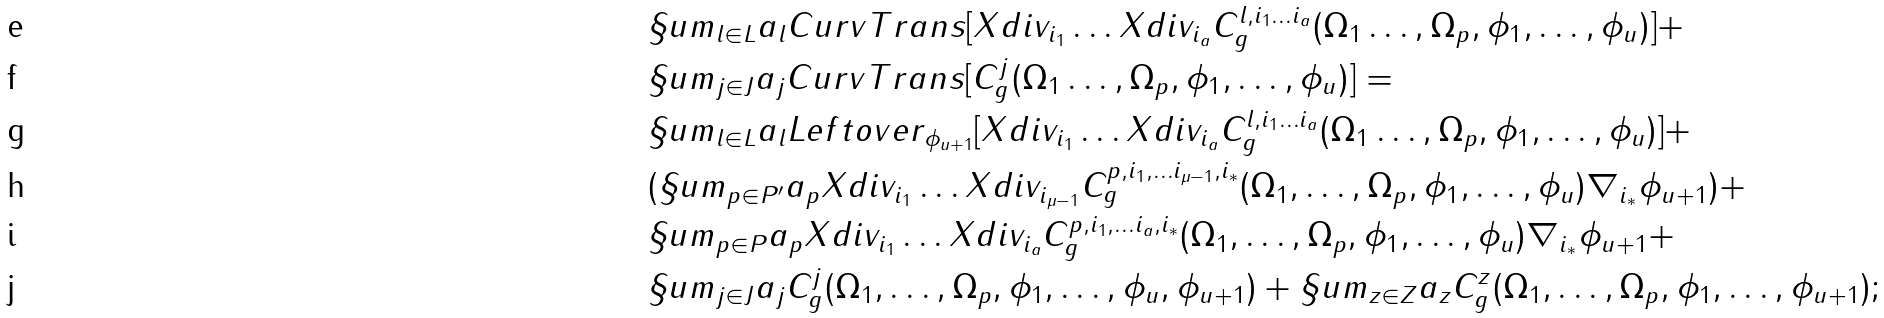Convert formula to latex. <formula><loc_0><loc_0><loc_500><loc_500>& \S u m _ { l \in L } a _ { l } C u r v T r a n s [ X d i v _ { i _ { 1 } } \dots X d i v _ { i _ { a } } C ^ { l , i _ { 1 } \dots i _ { a } } _ { g } ( \Omega _ { 1 } \dots , \Omega _ { p } , \phi _ { 1 } , \dots , \phi _ { u } ) ] + \\ & \S u m _ { j \in J } a _ { j } C u r v T r a n s [ C ^ { j } _ { g } ( \Omega _ { 1 } \dots , \Omega _ { p } , \phi _ { 1 } , \dots , \phi _ { u } ) ] = \\ & \S u m _ { l \in L } a _ { l } L e f t o v e r _ { \phi _ { u + 1 } } [ X d i v _ { i _ { 1 } } \dots X d i v _ { i _ { a } } C ^ { l , i _ { 1 } \dots i _ { a } } _ { g } ( \Omega _ { 1 } \dots , \Omega _ { p } , \phi _ { 1 } , \dots , \phi _ { u } ) ] + \\ & ( \S u m _ { p \in P ^ { \prime } } a _ { p } X d i v _ { i _ { 1 } } \dots X d i v _ { i _ { \mu - 1 } } C ^ { p , i _ { 1 } , \dots i _ { \mu - 1 } , i _ { * } } _ { g } ( \Omega _ { 1 } , \dots , \Omega _ { p } , \phi _ { 1 } , \dots , \phi _ { u } ) \nabla _ { i _ { * } } \phi _ { u + 1 } ) + \\ & \S u m _ { p \in P } a _ { p } X d i v _ { i _ { 1 } } \dots X d i v _ { i _ { a } } C ^ { p , i _ { 1 } , \dots i _ { a } , i _ { * } } _ { g } ( \Omega _ { 1 } , \dots , \Omega _ { p } , \phi _ { 1 } , \dots , \phi _ { u } ) \nabla _ { i _ { * } } \phi _ { u + 1 } + \\ & \S u m _ { j \in J } a _ { j } C ^ { j } _ { g } ( \Omega _ { 1 } , \dots , \Omega _ { p } , \phi _ { 1 } , \dots , \phi _ { u } , \phi _ { u + 1 } ) + \S u m _ { z \in Z } a _ { z } C ^ { z } _ { g } ( \Omega _ { 1 } , \dots , \Omega _ { p } , \phi _ { 1 } , \dots , \phi _ { u + 1 } ) ;</formula> 